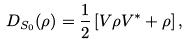Convert formula to latex. <formula><loc_0><loc_0><loc_500><loc_500>D _ { S _ { 0 } } ( \rho ) = \frac { 1 } { 2 } \left [ V \rho V ^ { * } + \rho \right ] ,</formula> 